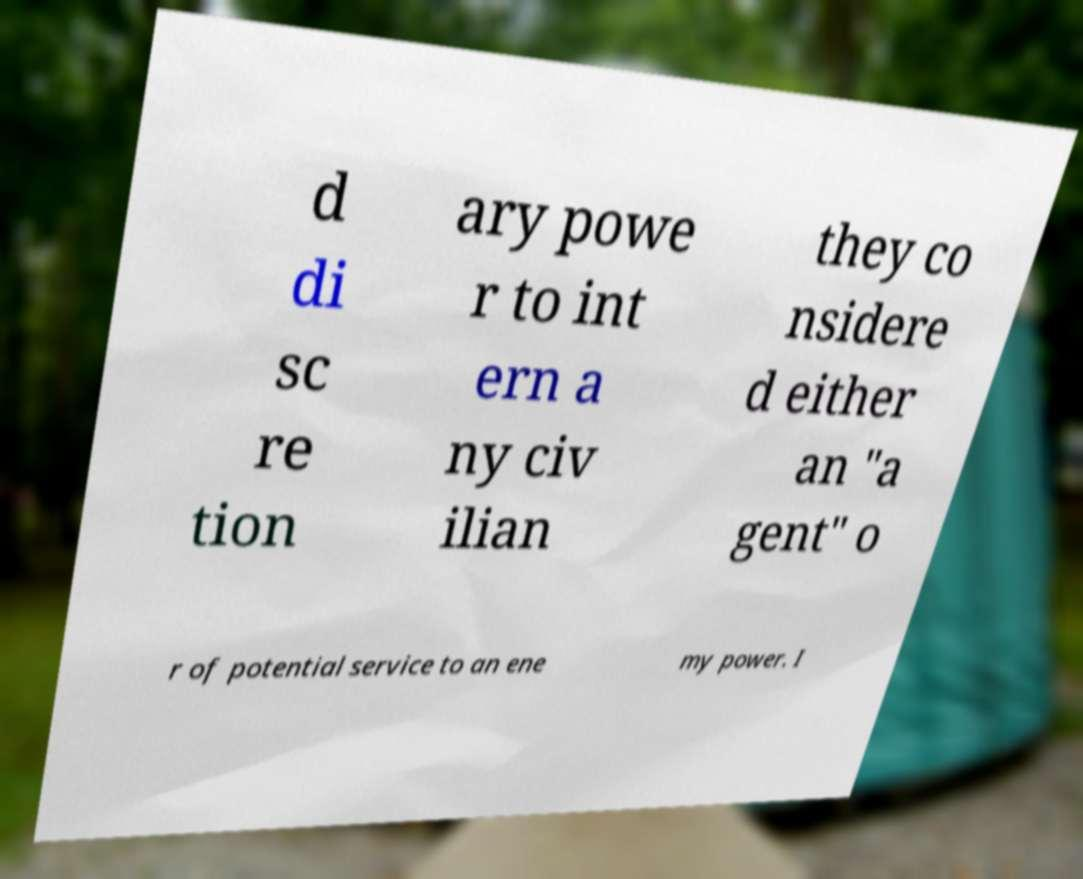There's text embedded in this image that I need extracted. Can you transcribe it verbatim? d di sc re tion ary powe r to int ern a ny civ ilian they co nsidere d either an "a gent" o r of potential service to an ene my power. I 